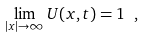<formula> <loc_0><loc_0><loc_500><loc_500>\lim _ { | { x } | \rightarrow \infty } U ( { x } , t ) = 1 \ ,</formula> 